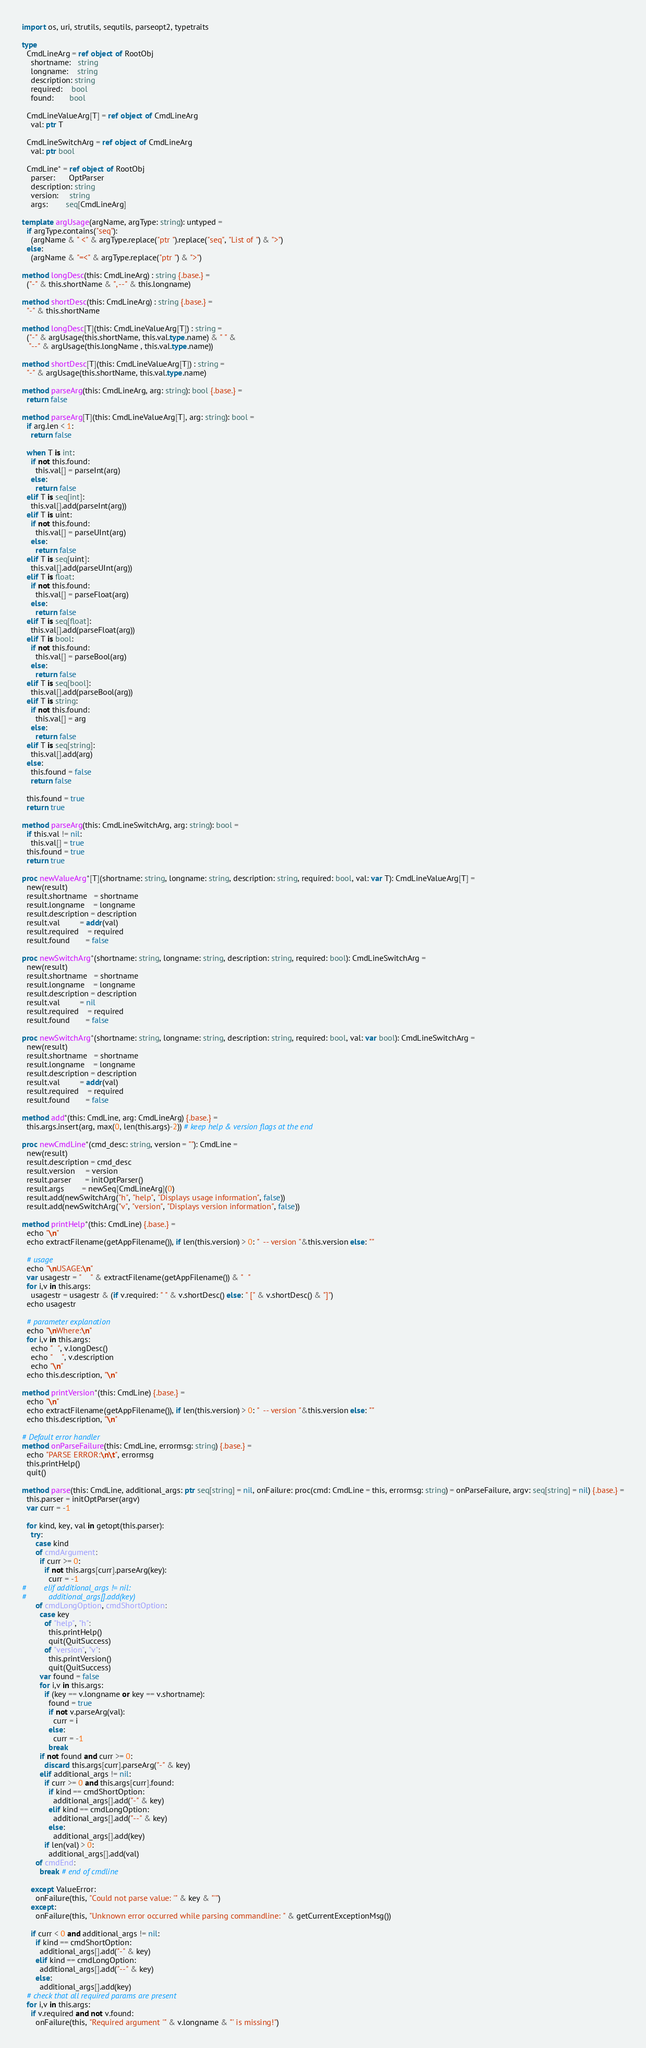Convert code to text. <code><loc_0><loc_0><loc_500><loc_500><_Nim_>import os, uri, strutils, sequtils, parseopt2, typetraits

type
  CmdLineArg = ref object of RootObj
    shortname:   string
    longname:    string
    description: string
    required:    bool
    found:       bool

  CmdLineValueArg[T] = ref object of CmdLineArg
    val: ptr T

  CmdLineSwitchArg = ref object of CmdLineArg
    val: ptr bool

  CmdLine* = ref object of RootObj
    parser:      OptParser
    description: string
    version:     string
    args:        seq[CmdLineArg]

template argUsage(argName, argType: string): untyped =
  if argType.contains("seq"):
    (argName & " <" & argType.replace("ptr ").replace("seq", "List of ") & ">")
  else:
    (argName & "=<" & argType.replace("ptr ") & ">")

method longDesc(this: CmdLineArg) : string {.base.} =
  ("-" & this.shortName & ", --" & this.longname)

method shortDesc(this: CmdLineArg) : string {.base.} =
  "-" & this.shortName

method longDesc[T](this: CmdLineValueArg[T]) : string =
  ("-" & argUsage(this.shortName, this.val.type.name) & " " &
   "--" & argUsage(this.longName , this.val.type.name))

method shortDesc[T](this: CmdLineValueArg[T]) : string =
  "-" & argUsage(this.shortName, this.val.type.name)

method parseArg(this: CmdLineArg, arg: string): bool {.base.} =
  return false

method parseArg[T](this: CmdLineValueArg[T], arg: string): bool =
  if arg.len < 1:
    return false

  when T is int:
    if not this.found:
      this.val[] = parseInt(arg)
    else:
      return false
  elif T is seq[int]:
    this.val[].add(parseInt(arg))
  elif T is uint:
    if not this.found:
      this.val[] = parseUInt(arg)
    else:
      return false
  elif T is seq[uint]:
    this.val[].add(parseUInt(arg))
  elif T is float:
    if not this.found:
      this.val[] = parseFloat(arg)
    else:
      return false
  elif T is seq[float]:
    this.val[].add(parseFloat(arg))
  elif T is bool:
    if not this.found:
      this.val[] = parseBool(arg)
    else:
      return false
  elif T is seq[bool]:
    this.val[].add(parseBool(arg))
  elif T is string:
    if not this.found:
      this.val[] = arg
    else:
      return false
  elif T is seq[string]:
    this.val[].add(arg)
  else:
    this.found = false
    return false

  this.found = true
  return true

method parseArg(this: CmdLineSwitchArg, arg: string): bool =
  if this.val != nil:
    this.val[] = true
  this.found = true
  return true

proc newValueArg*[T](shortname: string, longname: string, description: string, required: bool, val: var T): CmdLineValueArg[T] =
  new(result)
  result.shortname   = shortname
  result.longname    = longname
  result.description = description
  result.val         = addr(val)
  result.required    = required
  result.found       = false

proc newSwitchArg*(shortname: string, longname: string, description: string, required: bool): CmdLineSwitchArg =
  new(result)
  result.shortname   = shortname
  result.longname    = longname
  result.description = description
  result.val         = nil
  result.required    = required
  result.found       = false

proc newSwitchArg*(shortname: string, longname: string, description: string, required: bool, val: var bool): CmdLineSwitchArg =
  new(result)
  result.shortname   = shortname
  result.longname    = longname
  result.description = description
  result.val         = addr(val)
  result.required    = required
  result.found       = false

method add*(this: CmdLine, arg: CmdLineArg) {.base.} =
  this.args.insert(arg, max(0, len(this.args)-2)) # keep help & version flags at the end

proc newCmdLine*(cmd_desc: string, version = ""): CmdLine =
  new(result)
  result.description = cmd_desc
  result.version     = version
  result.parser      = initOptParser()
  result.args        = newSeq[CmdLineArg](0)
  result.add(newSwitchArg("h", "help", "Displays usage information", false))
  result.add(newSwitchArg("v", "version", "Displays version information", false))

method printHelp*(this: CmdLine) {.base.} =
  echo "\n"
  echo extractFilename(getAppFilename()), if len(this.version) > 0: "  -- version "&this.version else: ""

  # usage
  echo "\nUSAGE:\n"
  var usagestr = "    " & extractFilename(getAppFilename()) & "  "
  for i,v in this.args:
    usagestr = usagestr & (if v.required: " " & v.shortDesc() else: " [" & v.shortDesc() & "]")
  echo usagestr

  # parameter explanation
  echo "\nWhere:\n"
  for i,v in this.args:
    echo "  ", v.longDesc()
    echo "    ", v.description
    echo "\n"
  echo this.description, "\n"

method printVersion*(this: CmdLine) {.base.} =
  echo "\n"
  echo extractFilename(getAppFilename()), if len(this.version) > 0: "  -- version "&this.version else: ""
  echo this.description, "\n"

# Default error handler
method onParseFailure(this: CmdLine, errormsg: string) {.base.} =
  echo "PARSE ERROR:\n\t", errormsg
  this.printHelp()
  quit()

method parse(this: CmdLine, additional_args: ptr seq[string] = nil, onFailure: proc(cmd: CmdLine = this, errormsg: string) = onParseFailure, argv: seq[string] = nil) {.base.} =
  this.parser = initOptParser(argv)
  var curr = -1

  for kind, key, val in getopt(this.parser):
    try:
      case kind
      of cmdArgument:
        if curr >= 0:
          if not this.args[curr].parseArg(key):
            curr = -1
#        elif additional_args != nil:
#          additional_args[].add(key)
      of cmdLongOption, cmdShortOption:
        case key
          of "help", "h":
            this.printHelp()
            quit(QuitSuccess)
          of "version", "v":
            this.printVersion()
            quit(QuitSuccess)
        var found = false
        for i,v in this.args:
          if (key == v.longname or key == v.shortname):
            found = true
            if not v.parseArg(val):
              curr = i
            else:
              curr = -1
            break
        if not found and curr >= 0:
          discard this.args[curr].parseArg("-" & key)
        elif additional_args != nil:
          if curr >= 0 and this.args[curr].found:
            if kind == cmdShortOption:
              additional_args[].add("-" & key)
            elif kind == cmdLongOption:
              additional_args[].add("--" & key)
            else:
              additional_args[].add(key)
          if len(val) > 0:
            additional_args[].add(val)
      of cmdEnd:
        break # end of cmdline

    except ValueError:
      onFailure(this, "Could not parse value: '" & key & "'")
    except:
      onFailure(this, "Unknown error occurred while parsing commandline: " & getCurrentExceptionMsg())

    if curr < 0 and additional_args != nil:
      if kind == cmdShortOption:
        additional_args[].add("-" & key)
      elif kind == cmdLongOption:
        additional_args[].add("--" & key)
      else:
        additional_args[].add(key)
  # check that all required params are present
  for i,v in this.args:
    if v.required and not v.found:
      onFailure(this, "Required argument '" & v.longname & "' is missing!")
</code> 